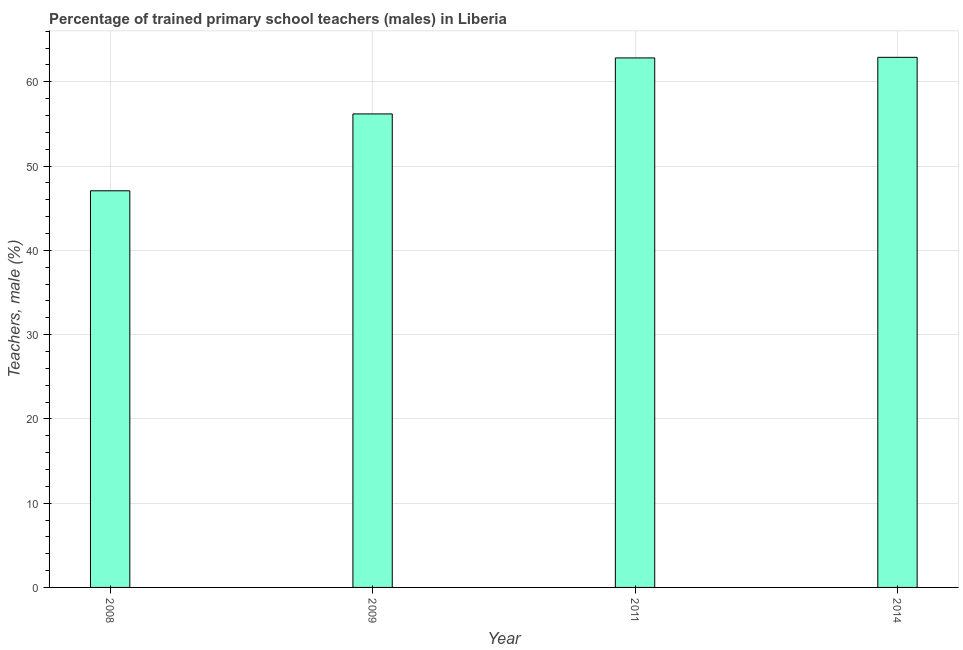Does the graph contain any zero values?
Give a very brief answer. No. Does the graph contain grids?
Give a very brief answer. Yes. What is the title of the graph?
Offer a very short reply. Percentage of trained primary school teachers (males) in Liberia. What is the label or title of the Y-axis?
Give a very brief answer. Teachers, male (%). What is the percentage of trained male teachers in 2008?
Offer a very short reply. 47.06. Across all years, what is the maximum percentage of trained male teachers?
Offer a very short reply. 62.9. Across all years, what is the minimum percentage of trained male teachers?
Make the answer very short. 47.06. In which year was the percentage of trained male teachers maximum?
Offer a very short reply. 2014. In which year was the percentage of trained male teachers minimum?
Make the answer very short. 2008. What is the sum of the percentage of trained male teachers?
Ensure brevity in your answer.  228.96. What is the difference between the percentage of trained male teachers in 2009 and 2014?
Provide a short and direct response. -6.71. What is the average percentage of trained male teachers per year?
Ensure brevity in your answer.  57.24. What is the median percentage of trained male teachers?
Your answer should be very brief. 59.5. In how many years, is the percentage of trained male teachers greater than 20 %?
Your answer should be compact. 4. Do a majority of the years between 2014 and 2009 (inclusive) have percentage of trained male teachers greater than 48 %?
Give a very brief answer. Yes. What is the ratio of the percentage of trained male teachers in 2008 to that in 2011?
Ensure brevity in your answer.  0.75. What is the difference between the highest and the second highest percentage of trained male teachers?
Make the answer very short. 0.07. What is the difference between the highest and the lowest percentage of trained male teachers?
Keep it short and to the point. 15.83. In how many years, is the percentage of trained male teachers greater than the average percentage of trained male teachers taken over all years?
Ensure brevity in your answer.  2. How many bars are there?
Your response must be concise. 4. How many years are there in the graph?
Offer a terse response. 4. What is the Teachers, male (%) of 2008?
Provide a short and direct response. 47.06. What is the Teachers, male (%) in 2009?
Offer a very short reply. 56.18. What is the Teachers, male (%) in 2011?
Keep it short and to the point. 62.83. What is the Teachers, male (%) of 2014?
Make the answer very short. 62.9. What is the difference between the Teachers, male (%) in 2008 and 2009?
Provide a short and direct response. -9.12. What is the difference between the Teachers, male (%) in 2008 and 2011?
Your response must be concise. -15.76. What is the difference between the Teachers, male (%) in 2008 and 2014?
Ensure brevity in your answer.  -15.83. What is the difference between the Teachers, male (%) in 2009 and 2011?
Offer a terse response. -6.64. What is the difference between the Teachers, male (%) in 2009 and 2014?
Provide a short and direct response. -6.71. What is the difference between the Teachers, male (%) in 2011 and 2014?
Your response must be concise. -0.07. What is the ratio of the Teachers, male (%) in 2008 to that in 2009?
Offer a very short reply. 0.84. What is the ratio of the Teachers, male (%) in 2008 to that in 2011?
Provide a short and direct response. 0.75. What is the ratio of the Teachers, male (%) in 2008 to that in 2014?
Your response must be concise. 0.75. What is the ratio of the Teachers, male (%) in 2009 to that in 2011?
Offer a terse response. 0.89. What is the ratio of the Teachers, male (%) in 2009 to that in 2014?
Your answer should be compact. 0.89. 